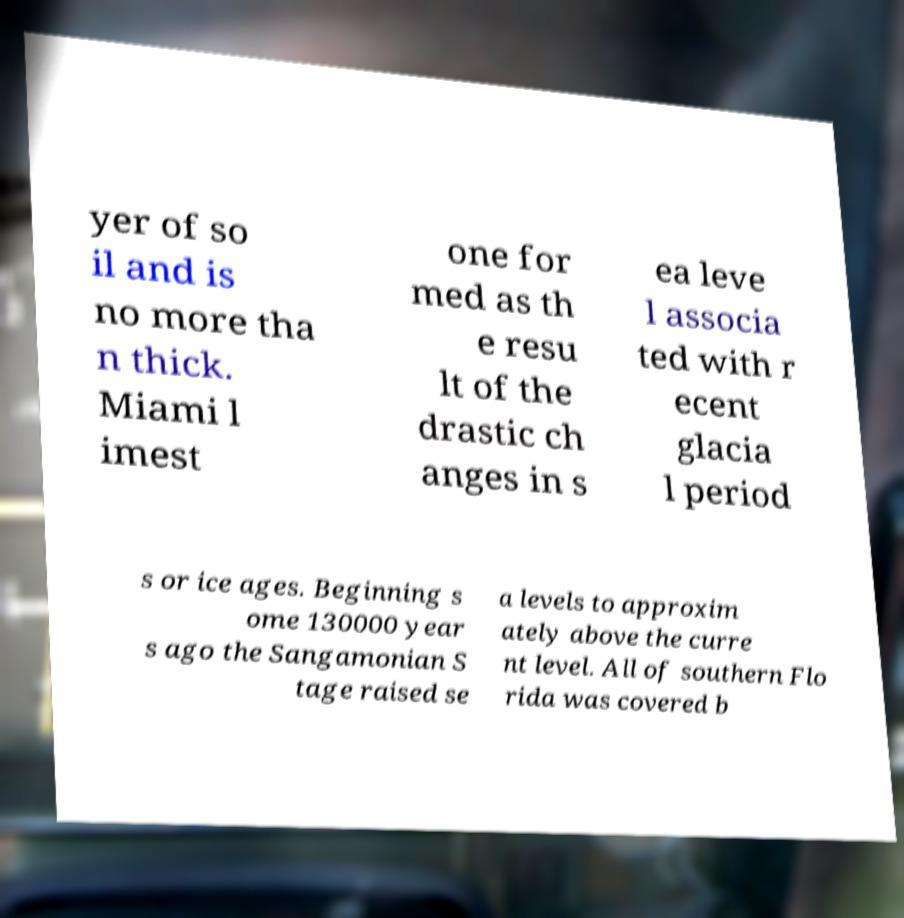Please identify and transcribe the text found in this image. yer of so il and is no more tha n thick. Miami l imest one for med as th e resu lt of the drastic ch anges in s ea leve l associa ted with r ecent glacia l period s or ice ages. Beginning s ome 130000 year s ago the Sangamonian S tage raised se a levels to approxim ately above the curre nt level. All of southern Flo rida was covered b 